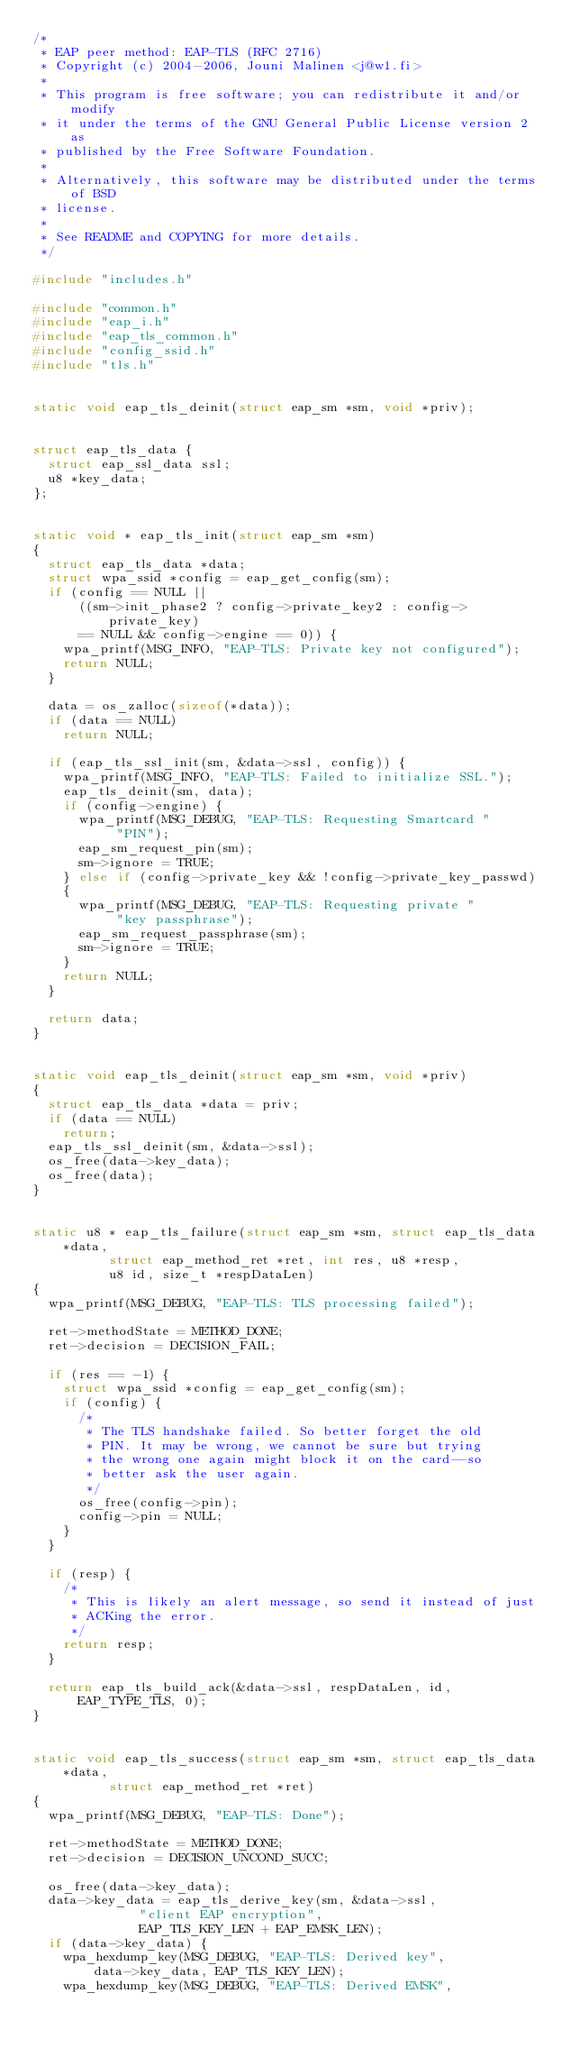Convert code to text. <code><loc_0><loc_0><loc_500><loc_500><_C_>/*
 * EAP peer method: EAP-TLS (RFC 2716)
 * Copyright (c) 2004-2006, Jouni Malinen <j@w1.fi>
 *
 * This program is free software; you can redistribute it and/or modify
 * it under the terms of the GNU General Public License version 2 as
 * published by the Free Software Foundation.
 *
 * Alternatively, this software may be distributed under the terms of BSD
 * license.
 *
 * See README and COPYING for more details.
 */

#include "includes.h"

#include "common.h"
#include "eap_i.h"
#include "eap_tls_common.h"
#include "config_ssid.h"
#include "tls.h"


static void eap_tls_deinit(struct eap_sm *sm, void *priv);


struct eap_tls_data {
	struct eap_ssl_data ssl;
	u8 *key_data;
};


static void * eap_tls_init(struct eap_sm *sm)
{
	struct eap_tls_data *data;
	struct wpa_ssid *config = eap_get_config(sm);
	if (config == NULL ||
	    ((sm->init_phase2 ? config->private_key2 : config->private_key)
	    == NULL && config->engine == 0)) {
		wpa_printf(MSG_INFO, "EAP-TLS: Private key not configured");
		return NULL;
	}

	data = os_zalloc(sizeof(*data));
	if (data == NULL)
		return NULL;

	if (eap_tls_ssl_init(sm, &data->ssl, config)) {
		wpa_printf(MSG_INFO, "EAP-TLS: Failed to initialize SSL.");
		eap_tls_deinit(sm, data);
		if (config->engine) {
			wpa_printf(MSG_DEBUG, "EAP-TLS: Requesting Smartcard "
				   "PIN");
			eap_sm_request_pin(sm);
			sm->ignore = TRUE;
		} else if (config->private_key && !config->private_key_passwd)
		{
			wpa_printf(MSG_DEBUG, "EAP-TLS: Requesting private "
				   "key passphrase");
			eap_sm_request_passphrase(sm);
			sm->ignore = TRUE;
		}
		return NULL;
	}

	return data;
}


static void eap_tls_deinit(struct eap_sm *sm, void *priv)
{
	struct eap_tls_data *data = priv;
	if (data == NULL)
		return;
	eap_tls_ssl_deinit(sm, &data->ssl);
	os_free(data->key_data);
	os_free(data);
}


static u8 * eap_tls_failure(struct eap_sm *sm, struct eap_tls_data *data,
			    struct eap_method_ret *ret, int res, u8 *resp,
			    u8 id, size_t *respDataLen)
{
	wpa_printf(MSG_DEBUG, "EAP-TLS: TLS processing failed");

	ret->methodState = METHOD_DONE;
	ret->decision = DECISION_FAIL;

	if (res == -1) {
		struct wpa_ssid *config = eap_get_config(sm);
		if (config) {
			/*
			 * The TLS handshake failed. So better forget the old
			 * PIN. It may be wrong, we cannot be sure but trying
			 * the wrong one again might block it on the card--so
			 * better ask the user again.
			 */
			os_free(config->pin);
			config->pin = NULL;
		}
	}

	if (resp) {
		/*
		 * This is likely an alert message, so send it instead of just
		 * ACKing the error.
		 */
		return resp;
	}

	return eap_tls_build_ack(&data->ssl, respDataLen, id, EAP_TYPE_TLS, 0);
}


static void eap_tls_success(struct eap_sm *sm, struct eap_tls_data *data,
			    struct eap_method_ret *ret)
{
	wpa_printf(MSG_DEBUG, "EAP-TLS: Done");

	ret->methodState = METHOD_DONE;
	ret->decision = DECISION_UNCOND_SUCC;

	os_free(data->key_data);
	data->key_data = eap_tls_derive_key(sm, &data->ssl,
					    "client EAP encryption",
					    EAP_TLS_KEY_LEN + EAP_EMSK_LEN);
	if (data->key_data) {
		wpa_hexdump_key(MSG_DEBUG, "EAP-TLS: Derived key",
				data->key_data, EAP_TLS_KEY_LEN);
		wpa_hexdump_key(MSG_DEBUG, "EAP-TLS: Derived EMSK",</code> 